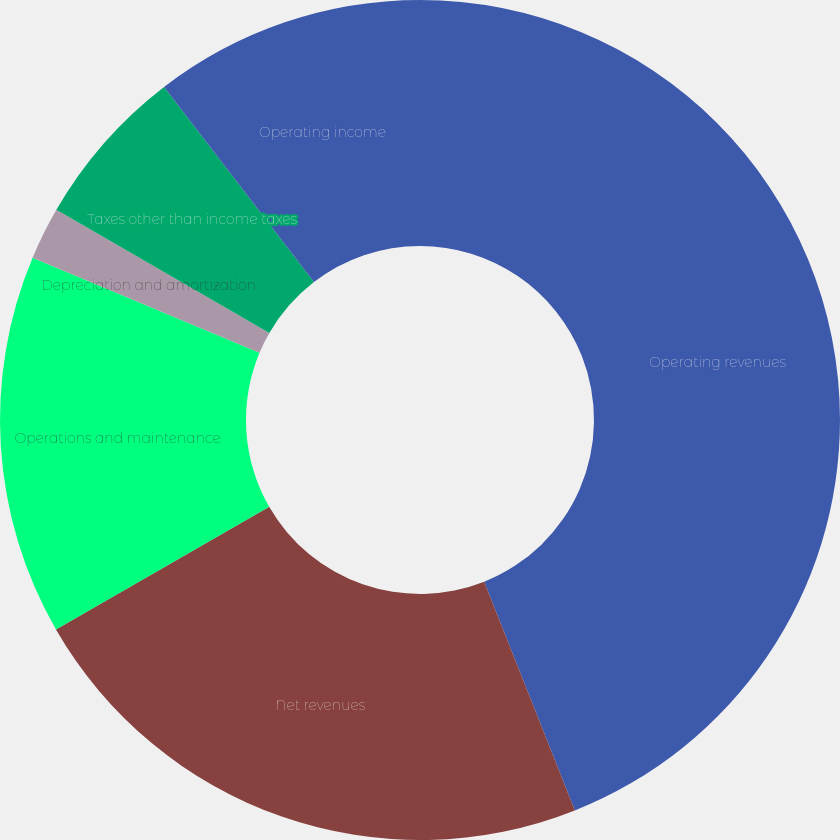<chart> <loc_0><loc_0><loc_500><loc_500><pie_chart><fcel>Operating revenues<fcel>Net revenues<fcel>Operations and maintenance<fcel>Depreciation and amortization<fcel>Taxes other than income taxes<fcel>Operating income<nl><fcel>43.99%<fcel>22.7%<fcel>14.62%<fcel>2.03%<fcel>6.23%<fcel>10.43%<nl></chart> 